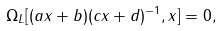Convert formula to latex. <formula><loc_0><loc_0><loc_500><loc_500>\Omega _ { L } [ ( a x + b ) ( c x + d ) ^ { - 1 } , x ] = 0 ,</formula> 